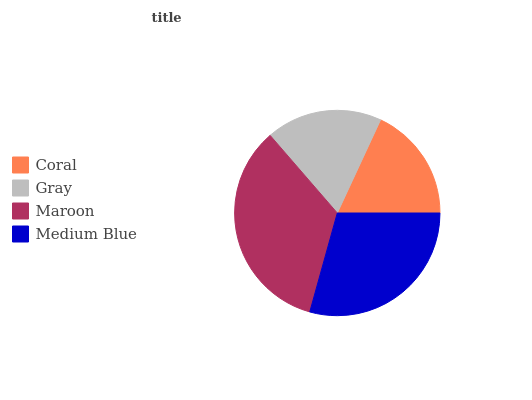Is Coral the minimum?
Answer yes or no. Yes. Is Maroon the maximum?
Answer yes or no. Yes. Is Gray the minimum?
Answer yes or no. No. Is Gray the maximum?
Answer yes or no. No. Is Gray greater than Coral?
Answer yes or no. Yes. Is Coral less than Gray?
Answer yes or no. Yes. Is Coral greater than Gray?
Answer yes or no. No. Is Gray less than Coral?
Answer yes or no. No. Is Medium Blue the high median?
Answer yes or no. Yes. Is Gray the low median?
Answer yes or no. Yes. Is Maroon the high median?
Answer yes or no. No. Is Medium Blue the low median?
Answer yes or no. No. 